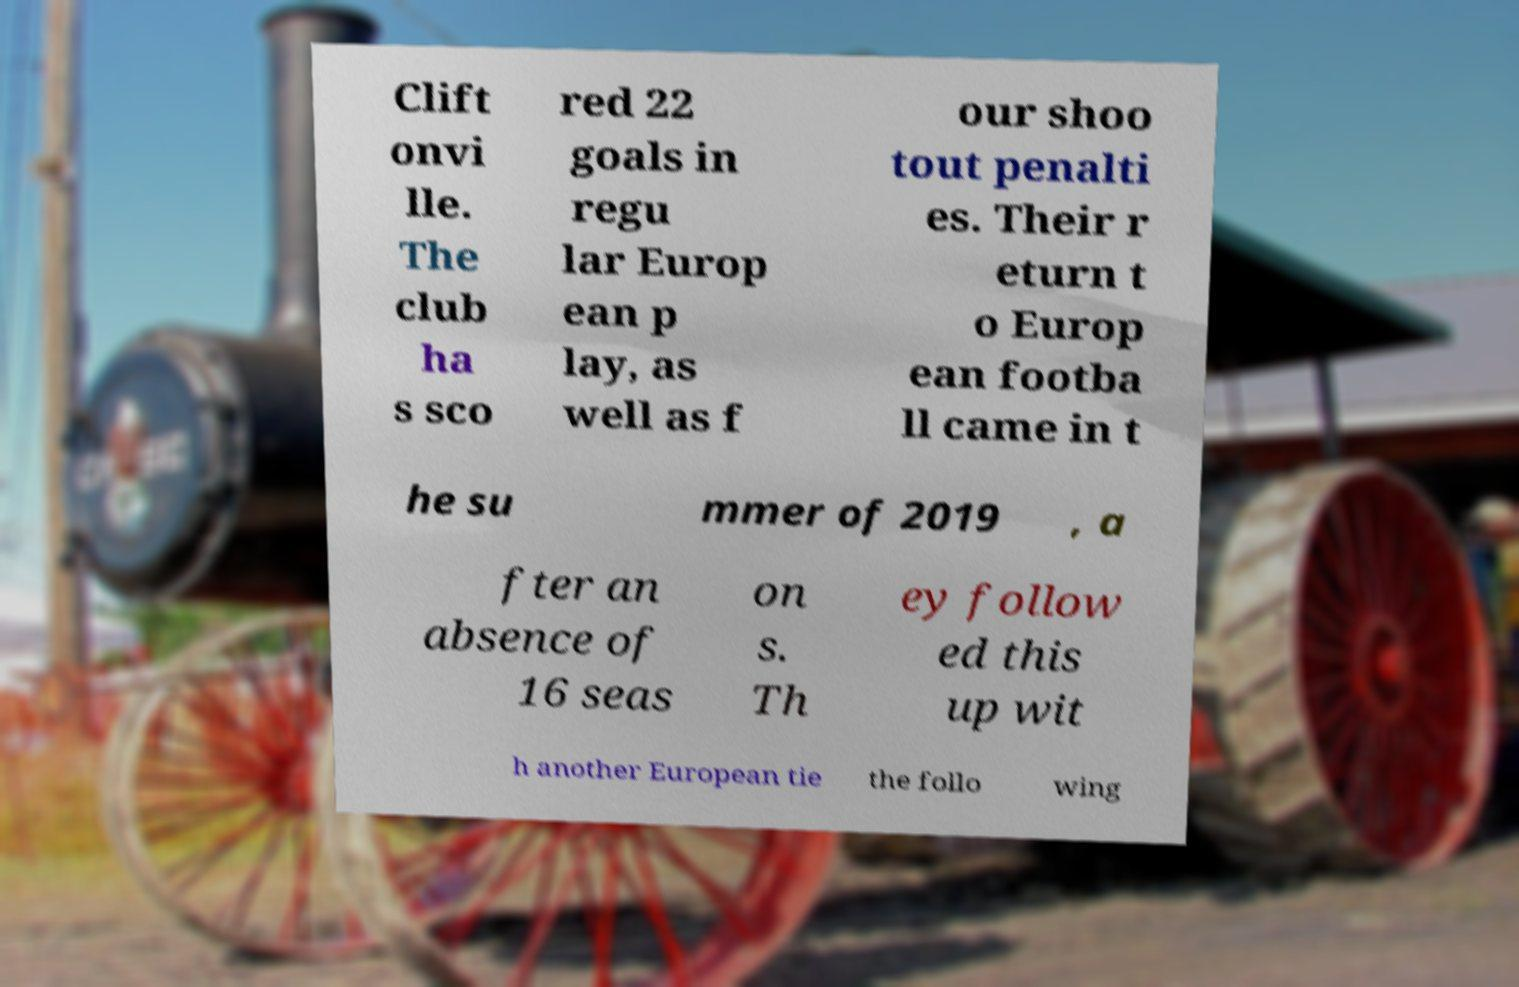I need the written content from this picture converted into text. Can you do that? Clift onvi lle. The club ha s sco red 22 goals in regu lar Europ ean p lay, as well as f our shoo tout penalti es. Their r eturn t o Europ ean footba ll came in t he su mmer of 2019 , a fter an absence of 16 seas on s. Th ey follow ed this up wit h another European tie the follo wing 